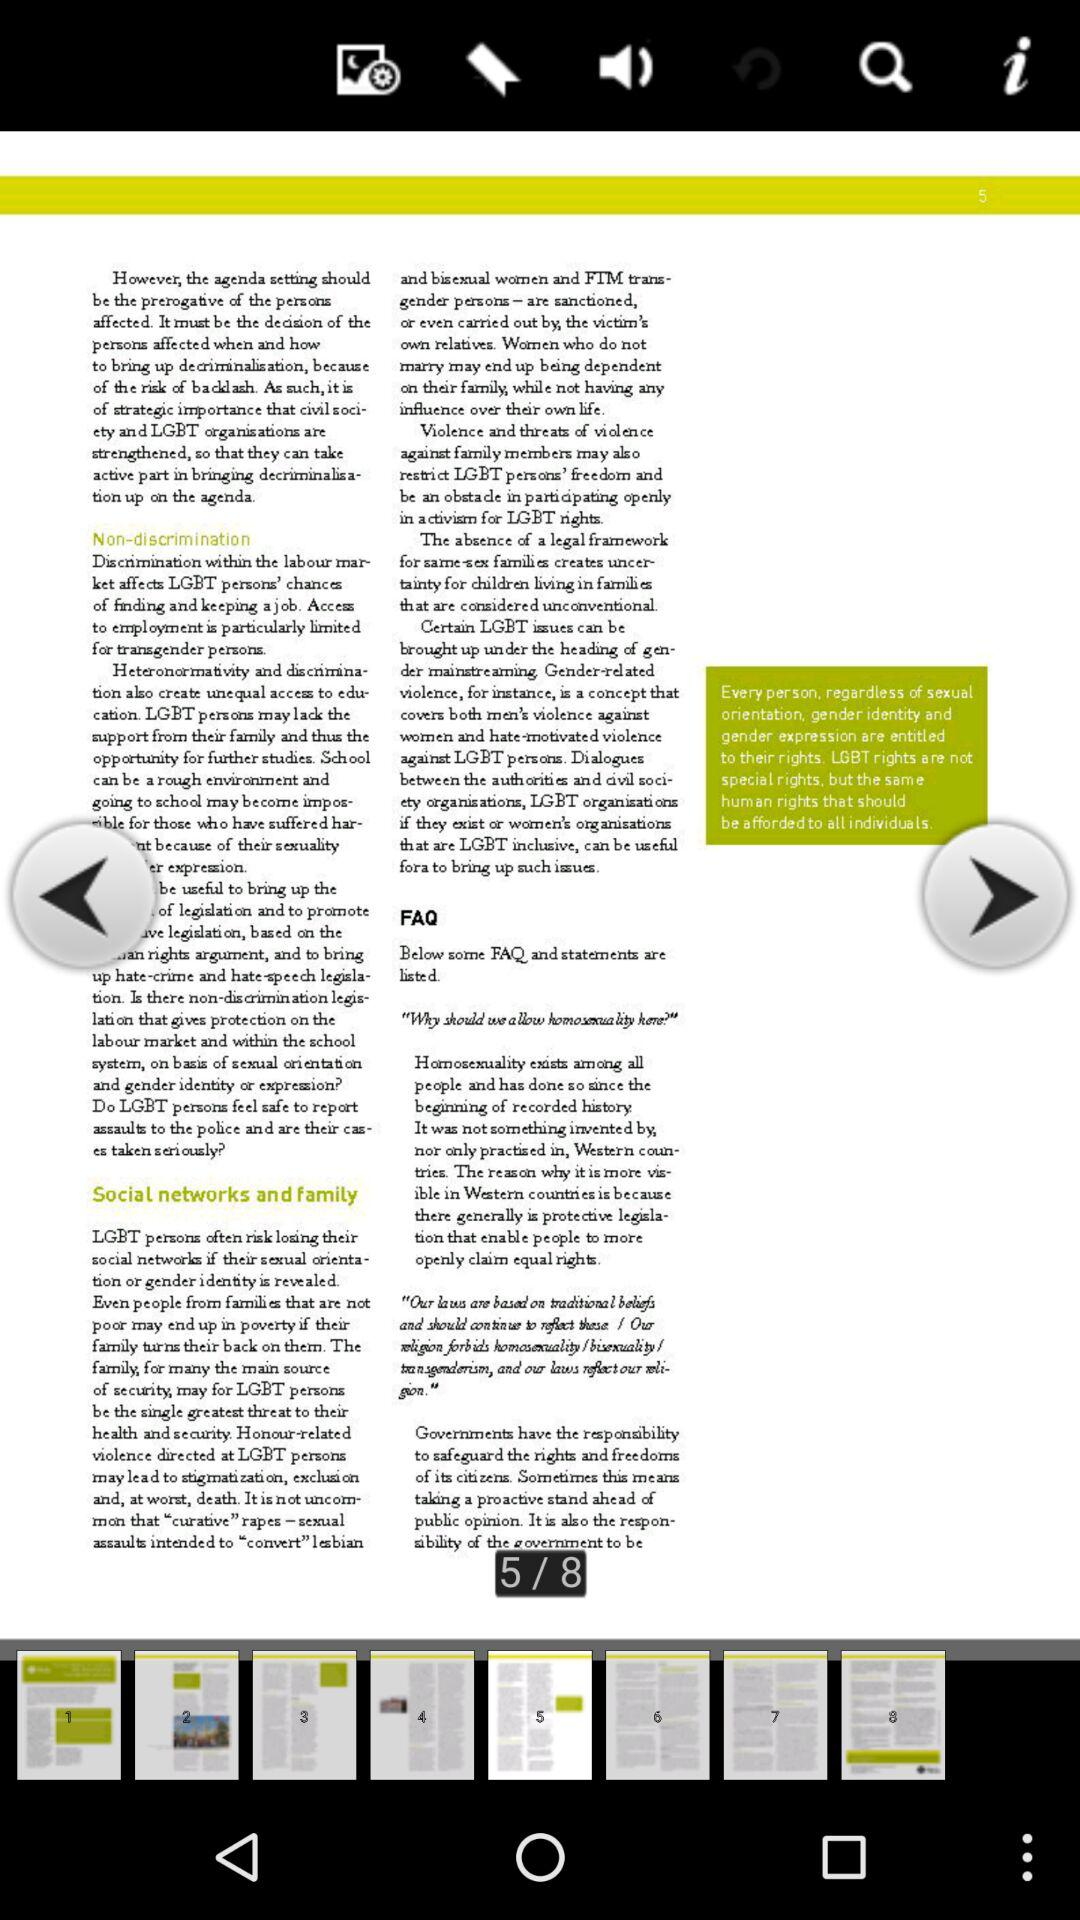What does page 6 say?
When the provided information is insufficient, respond with <no answer>. <no answer> 